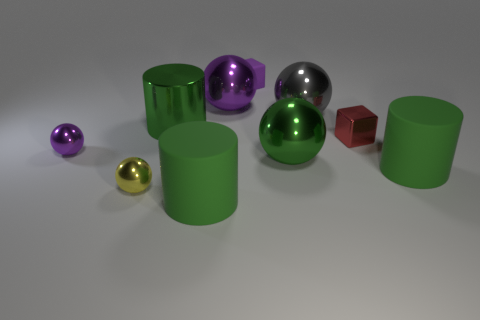Are there any tiny matte cubes to the left of the tiny purple cube?
Give a very brief answer. No. Is there a big green thing behind the small ball behind the yellow thing?
Offer a terse response. Yes. Is the number of green metallic objects that are behind the large green shiny cylinder the same as the number of green matte objects that are behind the large purple object?
Offer a terse response. Yes. The tiny cube that is made of the same material as the gray sphere is what color?
Ensure brevity in your answer.  Red. Are there any tiny purple blocks made of the same material as the tiny red cube?
Provide a succinct answer. No. How many objects are either large yellow metallic blocks or big green objects?
Your answer should be very brief. 4. Do the red cube and the green cylinder that is to the right of the red thing have the same material?
Your answer should be very brief. No. There is a green cylinder behind the tiny red metal cube; what size is it?
Offer a very short reply. Large. Are there fewer large cyan things than green things?
Your answer should be very brief. Yes. Are there any small matte blocks of the same color as the shiny block?
Provide a short and direct response. No. 